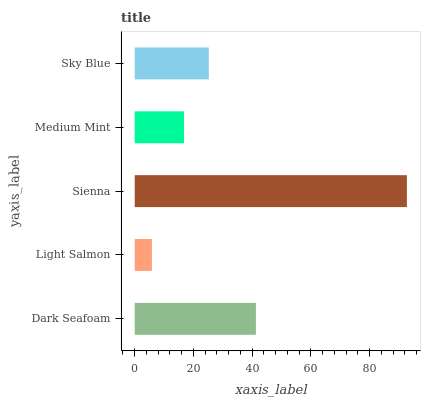Is Light Salmon the minimum?
Answer yes or no. Yes. Is Sienna the maximum?
Answer yes or no. Yes. Is Sienna the minimum?
Answer yes or no. No. Is Light Salmon the maximum?
Answer yes or no. No. Is Sienna greater than Light Salmon?
Answer yes or no. Yes. Is Light Salmon less than Sienna?
Answer yes or no. Yes. Is Light Salmon greater than Sienna?
Answer yes or no. No. Is Sienna less than Light Salmon?
Answer yes or no. No. Is Sky Blue the high median?
Answer yes or no. Yes. Is Sky Blue the low median?
Answer yes or no. Yes. Is Light Salmon the high median?
Answer yes or no. No. Is Light Salmon the low median?
Answer yes or no. No. 